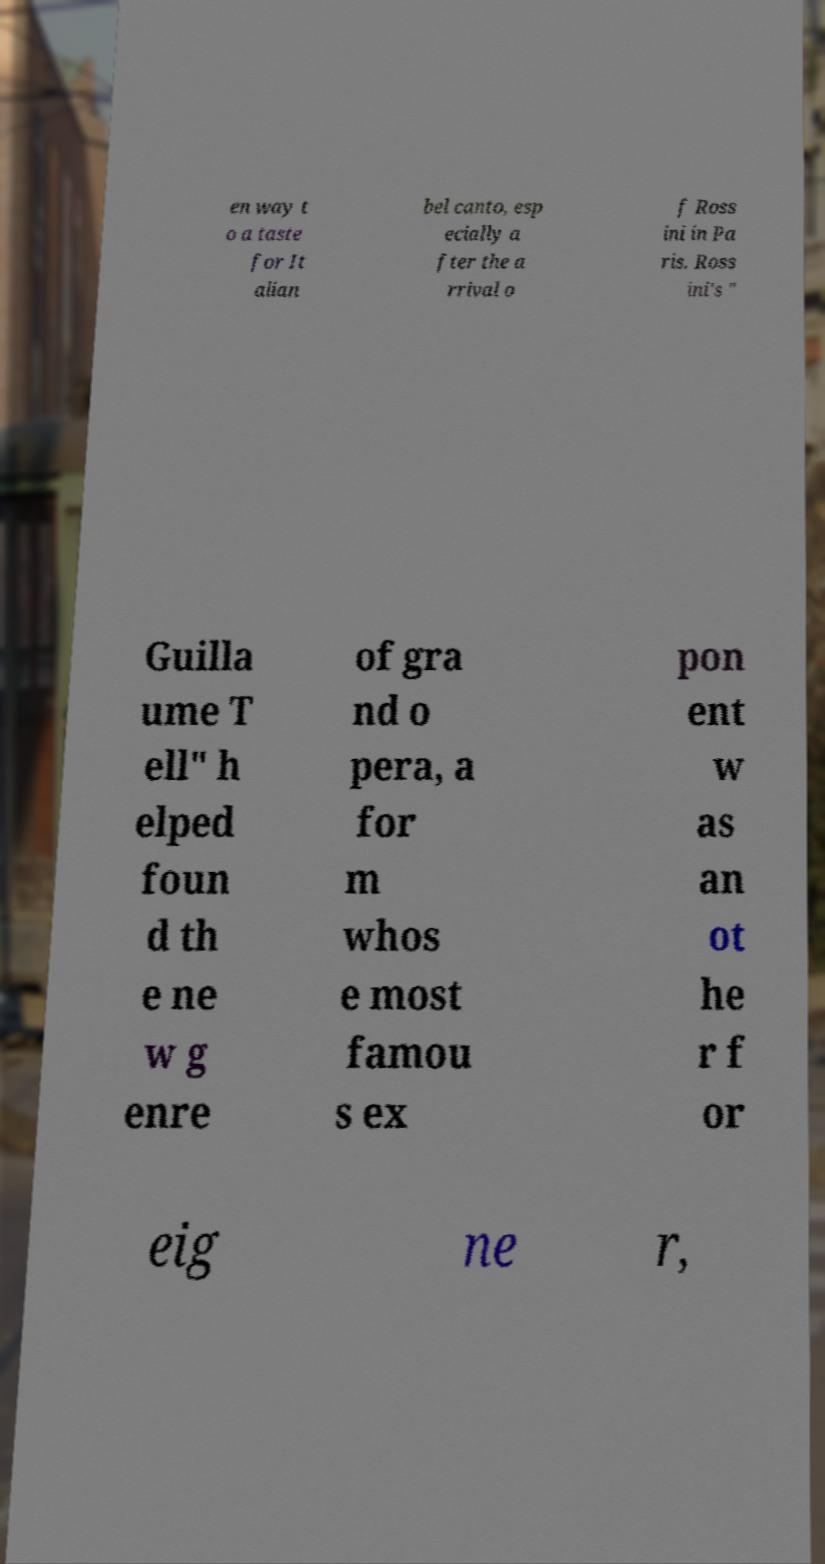There's text embedded in this image that I need extracted. Can you transcribe it verbatim? en way t o a taste for It alian bel canto, esp ecially a fter the a rrival o f Ross ini in Pa ris. Ross ini's " Guilla ume T ell" h elped foun d th e ne w g enre of gra nd o pera, a for m whos e most famou s ex pon ent w as an ot he r f or eig ne r, 